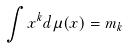<formula> <loc_0><loc_0><loc_500><loc_500>\int x ^ { k } d \mu ( x ) = m _ { k }</formula> 